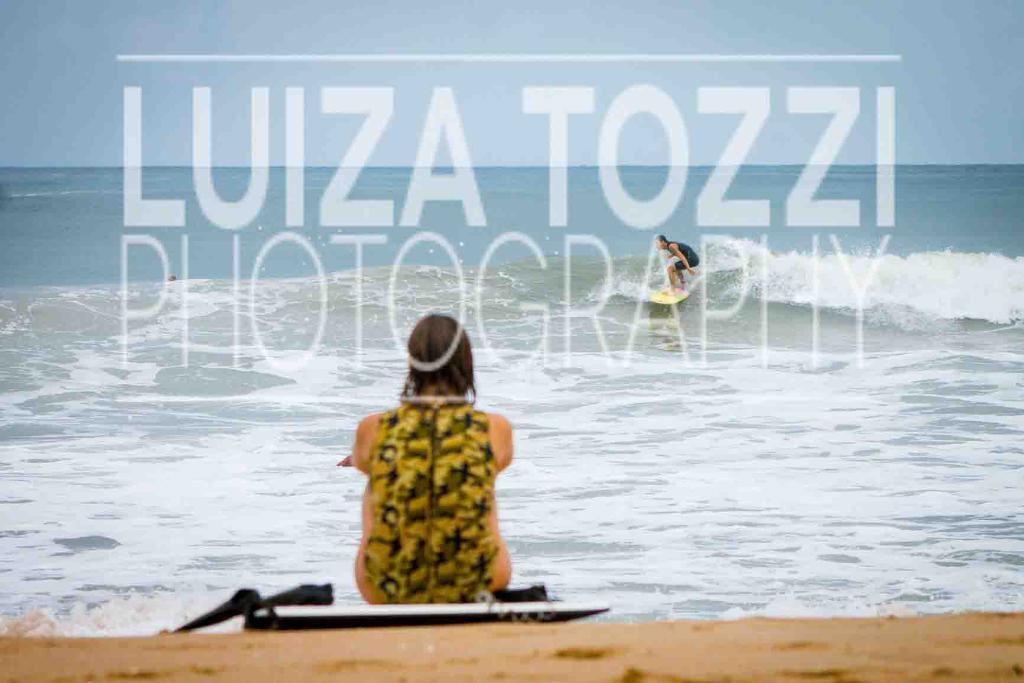Please provide a concise description of this image. This is a beach. Here I can see a woman is sitting on the ground facing towards the back side. At the back of her there is an object. In the background there is a person surfing board on the water. At the top of the image I can see the sky. On this image there is a watermark. 